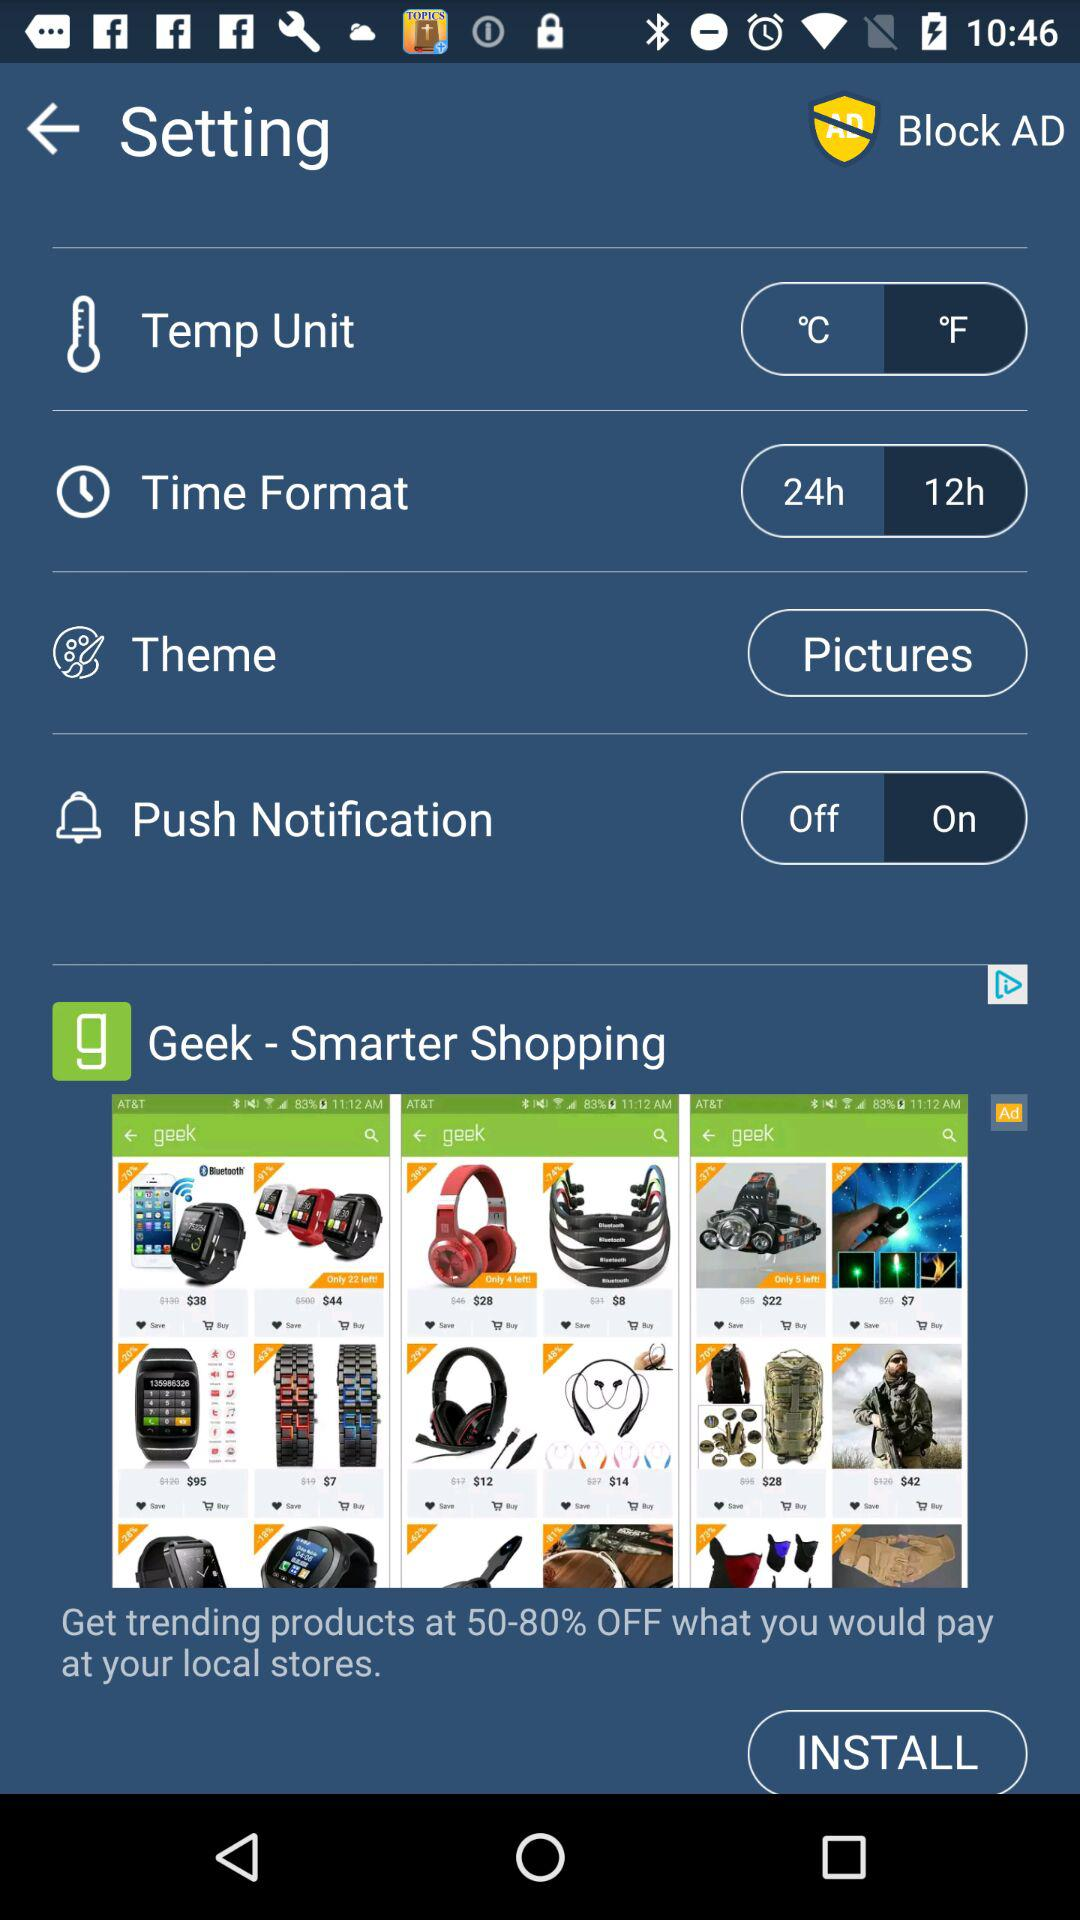What is the status for "Push Notification"? The status is "on". 